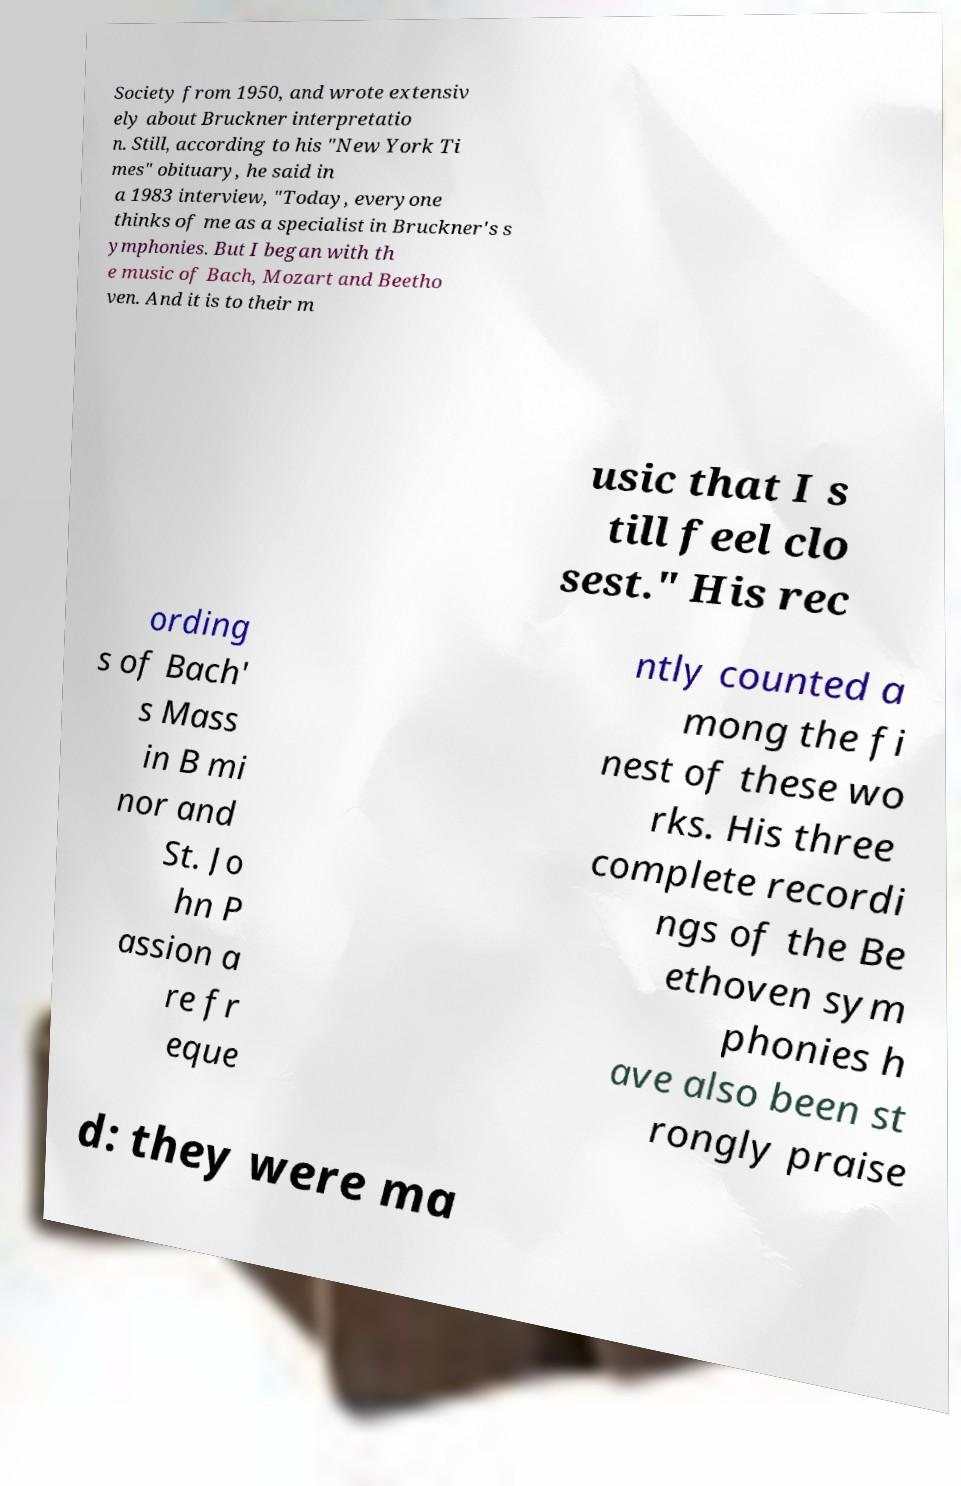I need the written content from this picture converted into text. Can you do that? Society from 1950, and wrote extensiv ely about Bruckner interpretatio n. Still, according to his "New York Ti mes" obituary, he said in a 1983 interview, "Today, everyone thinks of me as a specialist in Bruckner's s ymphonies. But I began with th e music of Bach, Mozart and Beetho ven. And it is to their m usic that I s till feel clo sest." His rec ording s of Bach' s Mass in B mi nor and St. Jo hn P assion a re fr eque ntly counted a mong the fi nest of these wo rks. His three complete recordi ngs of the Be ethoven sym phonies h ave also been st rongly praise d: they were ma 